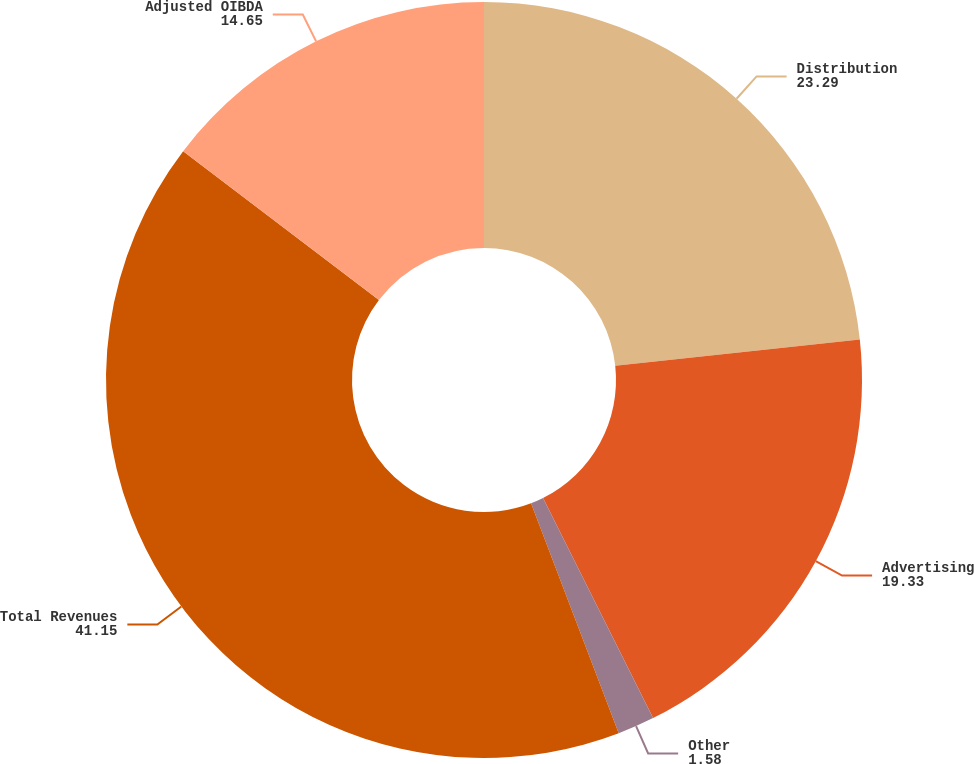Convert chart. <chart><loc_0><loc_0><loc_500><loc_500><pie_chart><fcel>Distribution<fcel>Advertising<fcel>Other<fcel>Total Revenues<fcel>Adjusted OIBDA<nl><fcel>23.29%<fcel>19.33%<fcel>1.58%<fcel>41.15%<fcel>14.65%<nl></chart> 